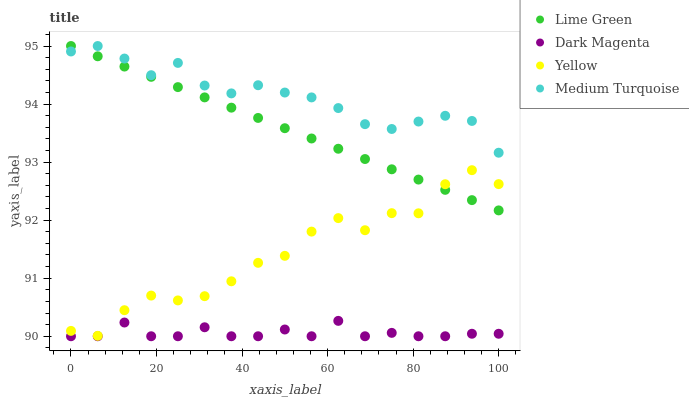Does Dark Magenta have the minimum area under the curve?
Answer yes or no. Yes. Does Medium Turquoise have the maximum area under the curve?
Answer yes or no. Yes. Does Lime Green have the minimum area under the curve?
Answer yes or no. No. Does Lime Green have the maximum area under the curve?
Answer yes or no. No. Is Lime Green the smoothest?
Answer yes or no. Yes. Is Yellow the roughest?
Answer yes or no. Yes. Is Dark Magenta the smoothest?
Answer yes or no. No. Is Dark Magenta the roughest?
Answer yes or no. No. Does Dark Magenta have the lowest value?
Answer yes or no. Yes. Does Lime Green have the lowest value?
Answer yes or no. No. Does Lime Green have the highest value?
Answer yes or no. Yes. Does Dark Magenta have the highest value?
Answer yes or no. No. Is Dark Magenta less than Medium Turquoise?
Answer yes or no. Yes. Is Medium Turquoise greater than Dark Magenta?
Answer yes or no. Yes. Does Lime Green intersect Medium Turquoise?
Answer yes or no. Yes. Is Lime Green less than Medium Turquoise?
Answer yes or no. No. Is Lime Green greater than Medium Turquoise?
Answer yes or no. No. Does Dark Magenta intersect Medium Turquoise?
Answer yes or no. No. 